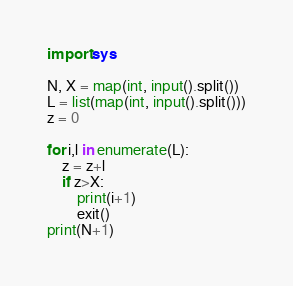Convert code to text. <code><loc_0><loc_0><loc_500><loc_500><_Python_>import sys

N, X = map(int, input().split())
L = list(map(int, input().split()))
z = 0

for i,l in enumerate(L):
    z = z+l
    if z>X:
        print(i+1)
        exit()
print(N+1)</code> 